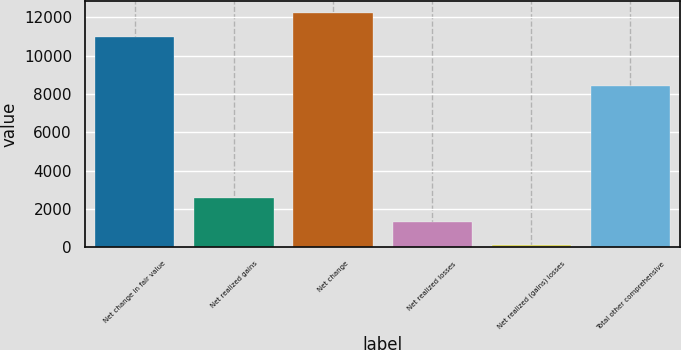Convert chart to OTSL. <chart><loc_0><loc_0><loc_500><loc_500><bar_chart><fcel>Net change in fair value<fcel>Net realized gains<fcel>Net change<fcel>Net realized losses<fcel>Net realized (gains) losses<fcel>Total other comprehensive<nl><fcel>10989<fcel>2558.4<fcel>12240<fcel>1348.2<fcel>138<fcel>8400<nl></chart> 